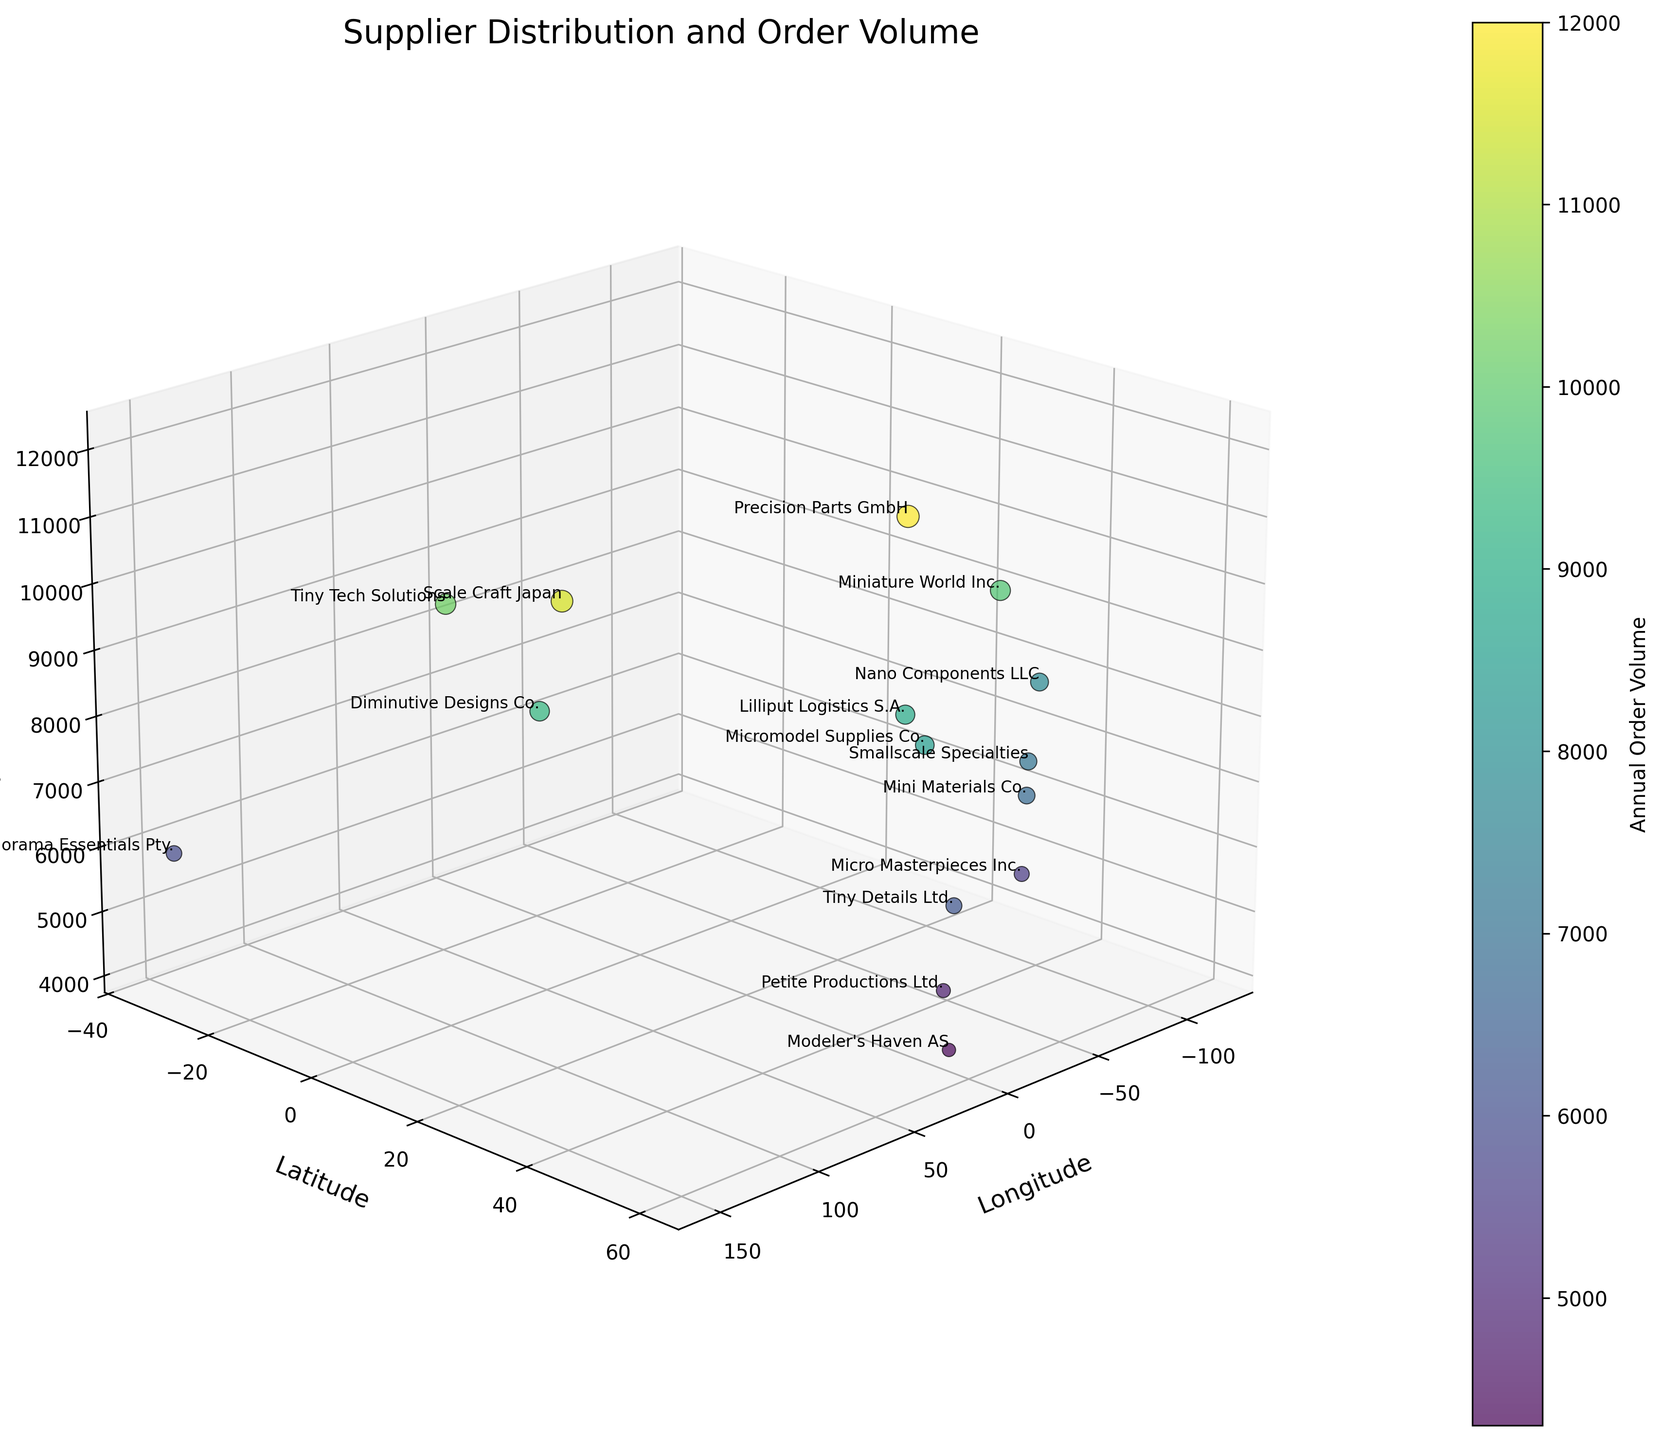What is the title of the figure? The title of the figure is prominently displayed at the top center of the plot.
Answer: Supplier Distribution and Order Volume How many suppliers are plotted on the figure? One can count all the labeled points in the 3D scatter plot.
Answer: 15 Which supplier has the highest annual order volume? By observing the color gradient of the points and the size of the markers, the supplier with the most vibrant color and largest marker indicates the highest annual order volume. This supplier is labeled on the plot.
Answer: Precision Parts GmbH Which supplier is located at the latitude of 34.0522 and longitude of -118.2437? By looking at the specific coordinates on the horizontal and vertical axis, the supplier located at this geographical position is identified by its label on the plot.
Answer: Nano Components LLC What is the total annual order volume for suppliers located in the United States? Identify the suppliers based in the United States by their geographical coordinates. Miniature World Inc., Micro Masterpieces Inc., Nano Components LLC, and Smallscale Specialties are the suppliers. Sum their annual order volumes: 9800 + 5500 + 7800 + 7100 = 30200.
Answer: 30200 How is the annual order volume distributed geographically? Observe the color and size of the markers across different geographical locations. Suppliers in urban areas like Europe, Asia, and the US have higher annual order volumes, indicated by more vibrant colors and larger markers. Suppliers in less populated regions have lower volumes.
Answer: Higher in urban areas, lower in less populated areas Which supplier has the lowest annual order volume and where is it located? Determine the smallest marker with the least vibrant color, indicating the lowest annual order volume, and refer to its label and coordinates.
Answer: Modeler's Haven AS, located in Oslo, Norway (59.9139, 10.7522) Are there any suppliers south of the equator? By examining the latitude coordinates, the only supplier located south of the equator should have a negative latitude. Identify this supplier in the figure.
Answer: Diorama Essentials Pty., located in Sydney, Australia What is the average annual order volume for suppliers in Europe? Identify suppliers located in Europe by their geographical coordinates: Micromodel Supplies Co., Precision Parts GmbH, Tiny Details Ltd., Scale Craft Japan, Lilliput Logistics S.A., and Petite Productions Ltd. Sum their annual order volumes and divide by the number of suppliers: (8500 + 12000 + 6200 + 11500 + 8900 + 4800) / 6 = 8391.67.
Answer: 8391.67 